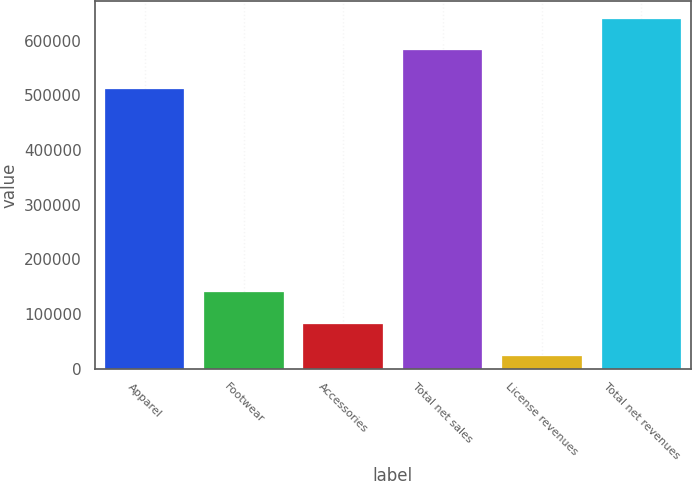<chart> <loc_0><loc_0><loc_500><loc_500><bar_chart><fcel>Apparel<fcel>Footwear<fcel>Accessories<fcel>Total net sales<fcel>License revenues<fcel>Total net revenues<nl><fcel>512613<fcel>140525<fcel>82270.5<fcel>582545<fcel>24016<fcel>640800<nl></chart> 